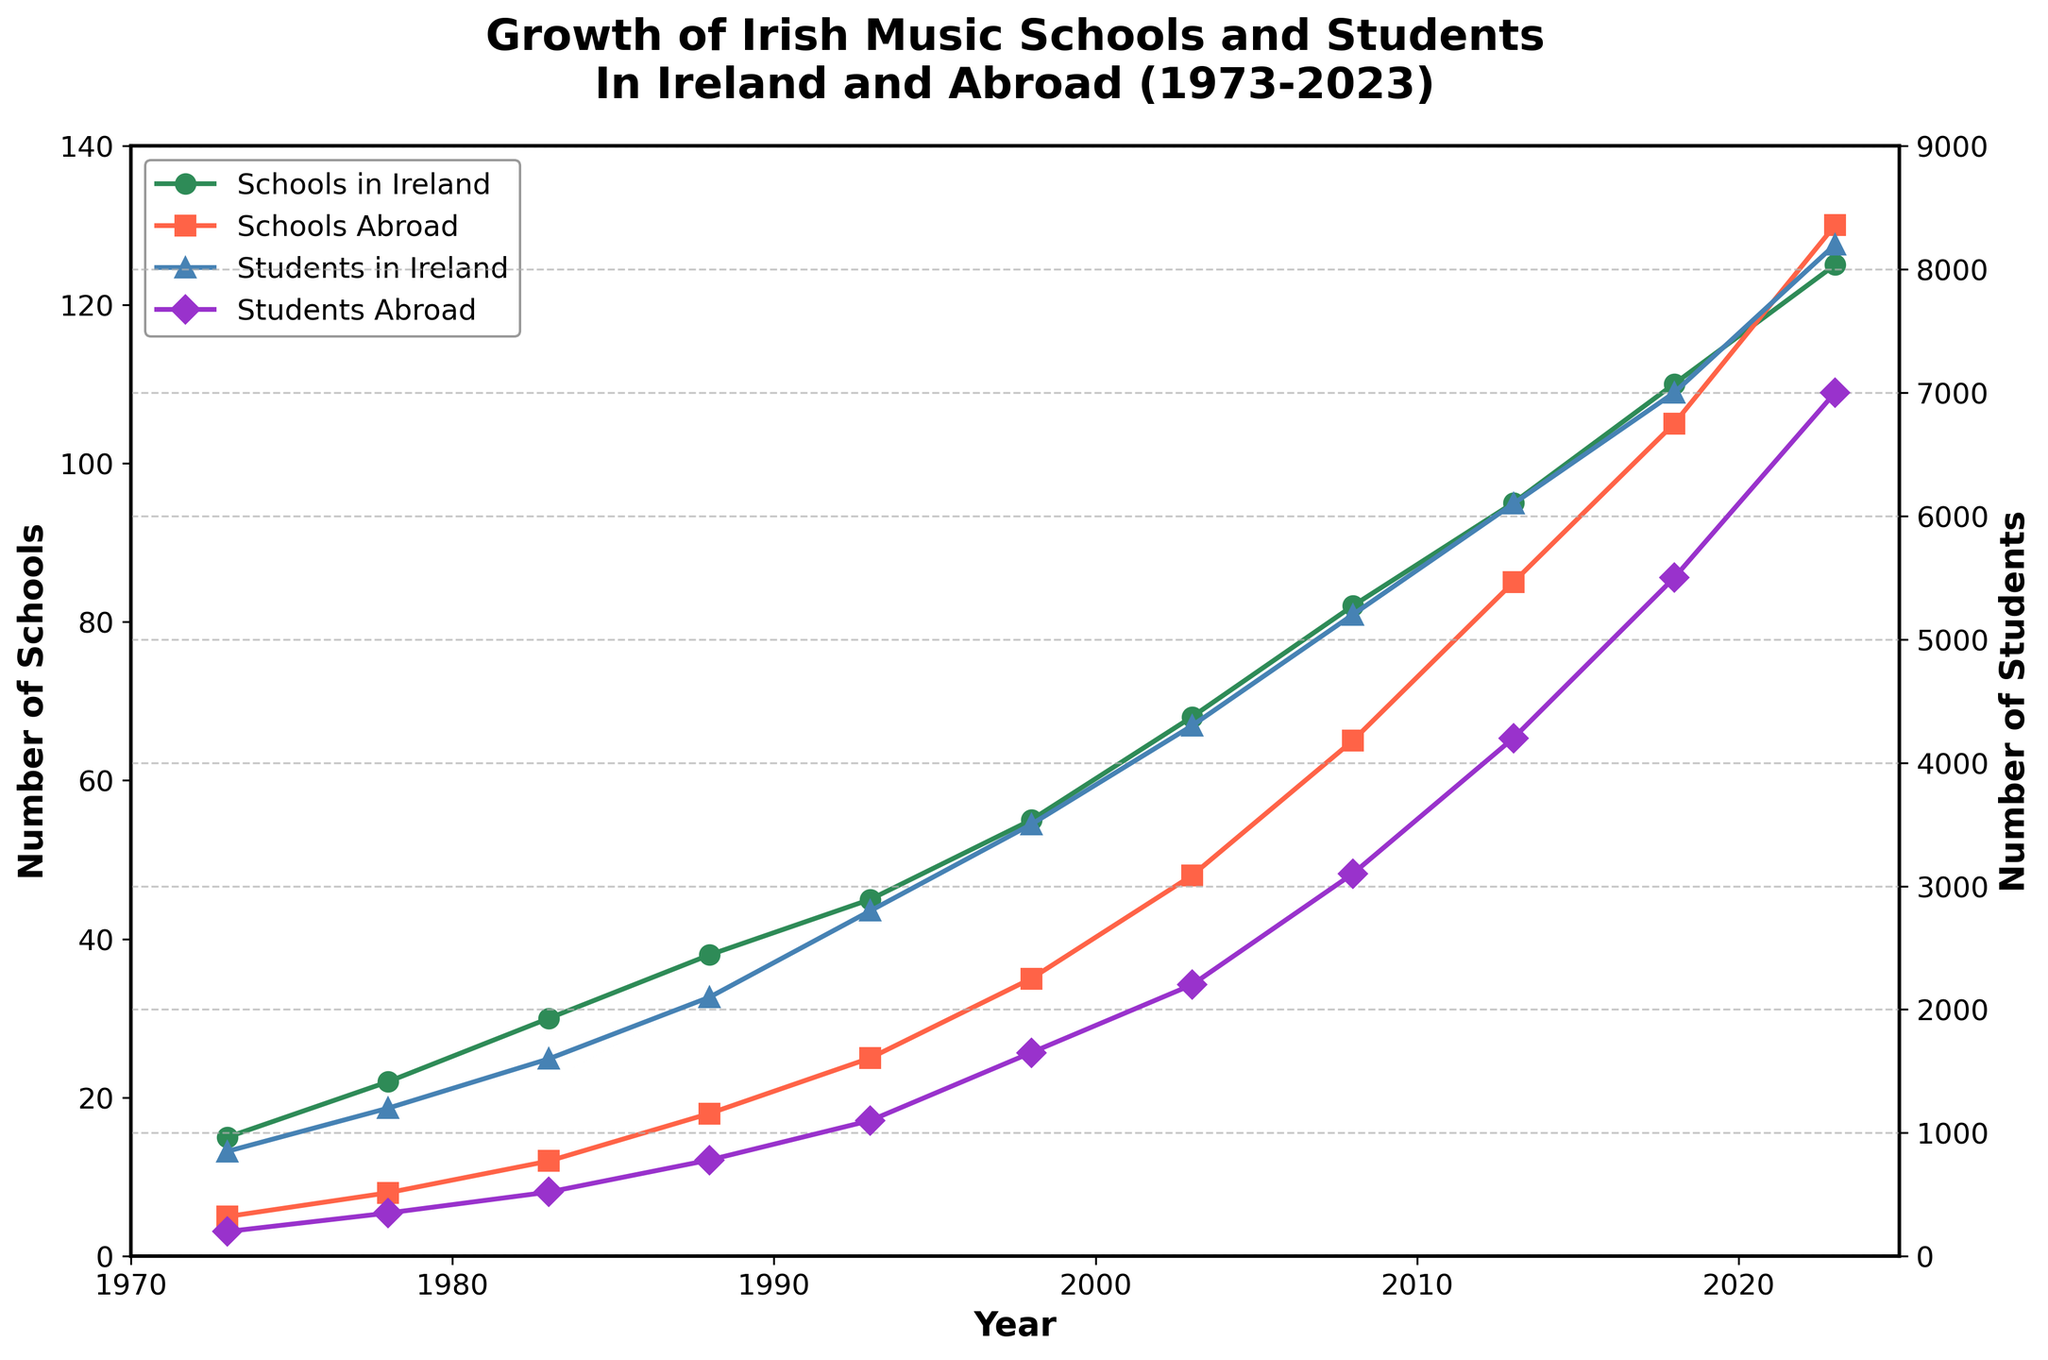How many years did it take for the number of Irish music schools in Ireland to double from 1973 levels? In 1973, there were 15 Irish music schools in Ireland. To find when this number doubled, we need to look for the first year the number reached at least 30. By 1983, the number of schools was 30, which is double the 1973 value. Therefore, it took 10 years (1983 - 1973).
Answer: 10 years Which year saw a greater relative increase in the number of students abroad compared to the previous year, 1993 or 2013? To find the relative increase, we compare the numbers to the previous year and calculate the percentage change. From 1988 to 1993, students abroad increased from 780 to 1100, [(1100 - 780) / 780] * 100 = 41.03%. From 2013 to 2018, students abroad increased from 4200 to 5500, [(5500 - 4200) / 4200] * 100 = 30.95%. Thus, 1993 saw a greater relative increase.
Answer: 1993 What is the difference in the number of students in Ireland in the years 2003 and 2023? To find the difference, subtract the number of students in Ireland in 2003 (4300) from the number in 2023 (8200). 8200 - 4300 = 3900.
Answer: 3900 Which line represents the growth of Irish music schools abroad, and what is its color? The figure shows each line with different colors and markers. The line for Irish music schools abroad is marked with squares ('s') and is colored red.
Answer: Red line with squares markers In which period (year range) did the Irish music schools in Ireland see the fastest growth, judging by the visual slope of the line? By looking at the steepness of the lines on the graph, the line representing schools in Ireland has the steepest slope between 1998 and 2003, indicating rapid growth during this period.
Answer: 1998-2003 By how many did the number of Irish music schools abroad increase from 1973 to 2023? In 1973, there were 5 Irish music schools abroad. By 2023, this number had risen to 130. The increase is calculated as 130 - 5 = 125.
Answer: 125 Are there more students abroad or in Ireland in 2018, and by how much? In 2018, the number of students in Ireland is 7000 and students abroad are 5500. To find out which is greater and by how much, subtract the smaller number from the larger one: 7000 - 5500 = 1500.
Answer: More in Ireland by 1500 What’s the total number of students, both in Ireland and abroad, in 2023? The total number of students in 2023 is the sum of students in Ireland and students abroad. In 2023, there are 8200 students in Ireland and 7000 abroad. So, the total is 8200 + 7000 = 15200.
Answer: 15200 